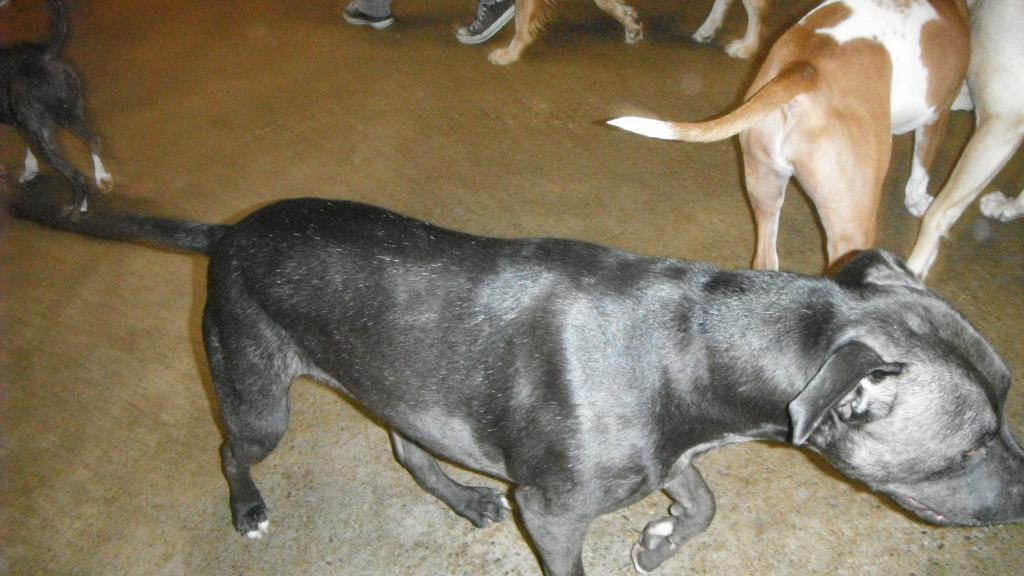What type of animal is in the image? There is a black color dog in the image. What is the dog doing in the image? The dog is walking in the middle of the image. Are there any other dogs visible in the image? Yes, there are other dogs on the right side of the image. How many rabbits can be seen traveling with the dog on its journey? There are no rabbits or journeys mentioned in the image; it only features a dog walking and other dogs nearby. 